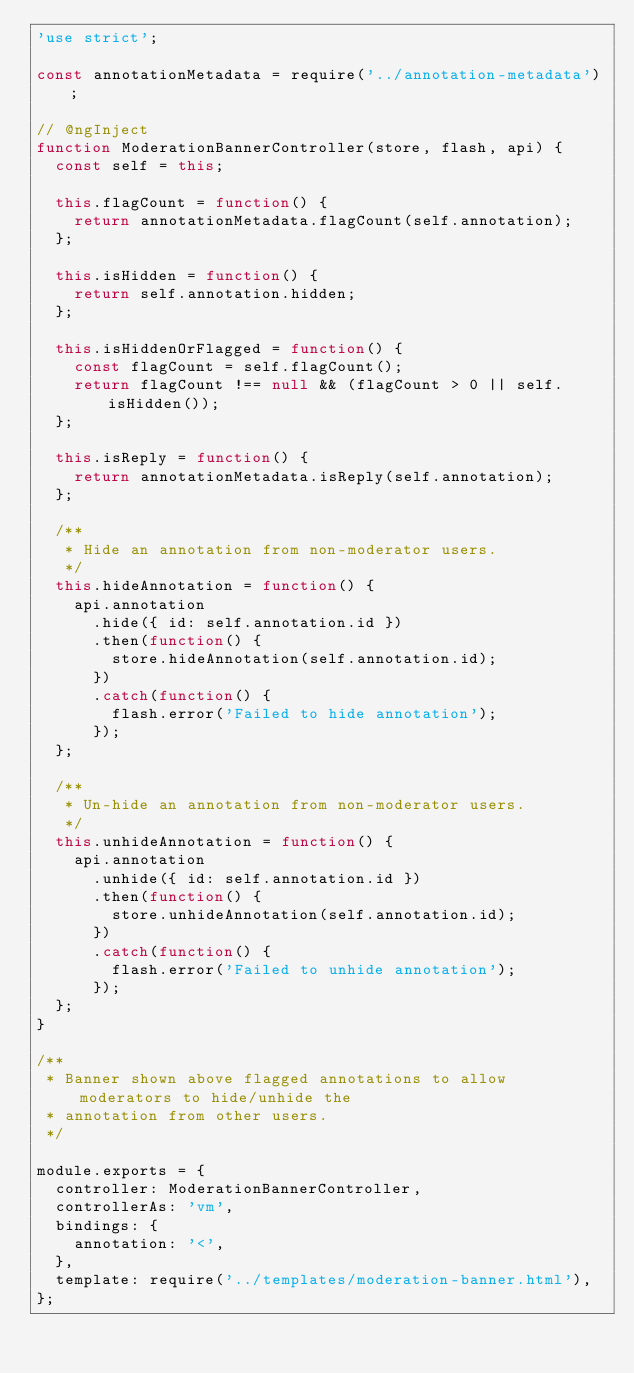<code> <loc_0><loc_0><loc_500><loc_500><_JavaScript_>'use strict';

const annotationMetadata = require('../annotation-metadata');

// @ngInject
function ModerationBannerController(store, flash, api) {
  const self = this;

  this.flagCount = function() {
    return annotationMetadata.flagCount(self.annotation);
  };

  this.isHidden = function() {
    return self.annotation.hidden;
  };

  this.isHiddenOrFlagged = function() {
    const flagCount = self.flagCount();
    return flagCount !== null && (flagCount > 0 || self.isHidden());
  };

  this.isReply = function() {
    return annotationMetadata.isReply(self.annotation);
  };

  /**
   * Hide an annotation from non-moderator users.
   */
  this.hideAnnotation = function() {
    api.annotation
      .hide({ id: self.annotation.id })
      .then(function() {
        store.hideAnnotation(self.annotation.id);
      })
      .catch(function() {
        flash.error('Failed to hide annotation');
      });
  };

  /**
   * Un-hide an annotation from non-moderator users.
   */
  this.unhideAnnotation = function() {
    api.annotation
      .unhide({ id: self.annotation.id })
      .then(function() {
        store.unhideAnnotation(self.annotation.id);
      })
      .catch(function() {
        flash.error('Failed to unhide annotation');
      });
  };
}

/**
 * Banner shown above flagged annotations to allow moderators to hide/unhide the
 * annotation from other users.
 */

module.exports = {
  controller: ModerationBannerController,
  controllerAs: 'vm',
  bindings: {
    annotation: '<',
  },
  template: require('../templates/moderation-banner.html'),
};
</code> 